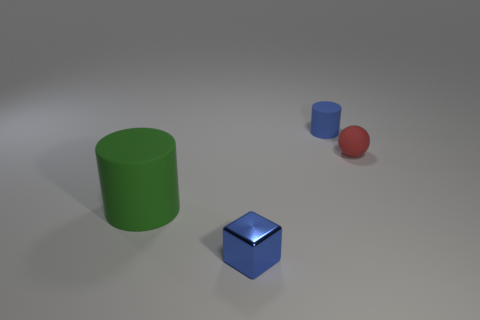What is the color of the rubber cylinder behind the matte thing that is on the left side of the tiny blue cylinder?
Provide a succinct answer. Blue. What color is the other rubber thing that is the same shape as the blue rubber thing?
Offer a very short reply. Green. What number of tiny cylinders are the same color as the big cylinder?
Provide a succinct answer. 0. Is the color of the large matte cylinder the same as the object that is behind the tiny red rubber ball?
Offer a terse response. No. There is a rubber object that is on the left side of the rubber sphere and on the right side of the green cylinder; what is its shape?
Provide a short and direct response. Cylinder. There is a tiny blue object in front of the thing on the right side of the cylinder that is behind the large matte object; what is its material?
Your answer should be very brief. Metal. Are there more green cylinders left of the green rubber object than blue cubes behind the small blue block?
Your answer should be compact. No. How many blue blocks are the same material as the small sphere?
Offer a terse response. 0. There is a blue object behind the small blue cube; does it have the same shape as the matte thing on the left side of the shiny cube?
Offer a terse response. Yes. There is a rubber cylinder in front of the tiny blue rubber cylinder; what is its color?
Provide a short and direct response. Green. 